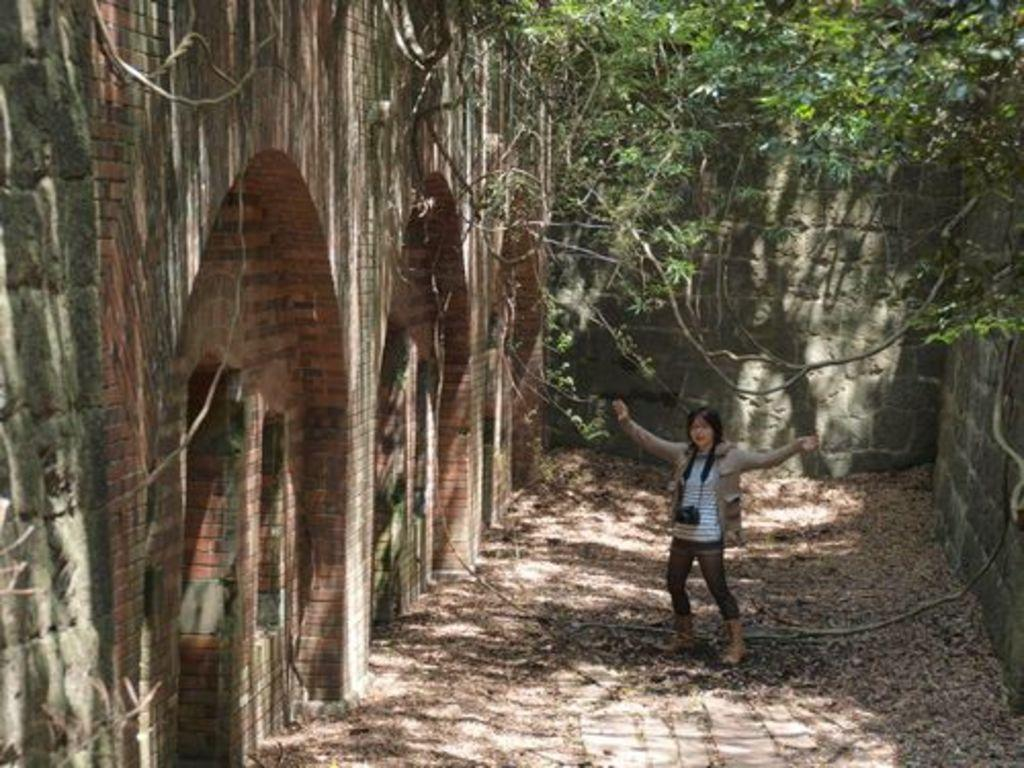What is the main subject of the image? There is a woman standing in the image. Where is the woman standing? The woman is standing on the ground. What is the woman wearing? The woman is wearing a camera. What can be seen in the background of the image? There is a wall, trees, and dried leaves in the background of the image. How many pages of the book can be seen in the image? There is no book present in the image, so it is not possible to determine the number of pages. 